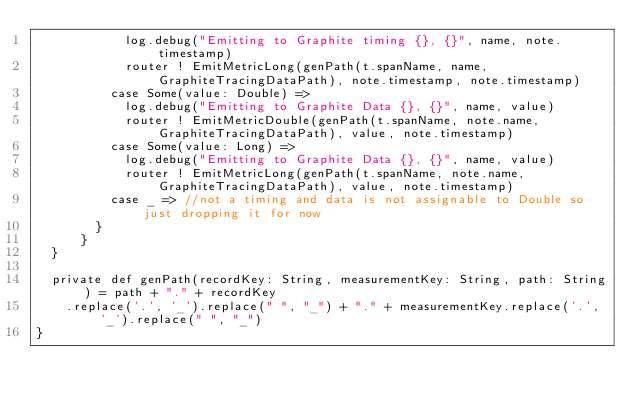Convert code to text. <code><loc_0><loc_0><loc_500><loc_500><_Scala_>            log.debug("Emitting to Graphite timing {}, {}", name, note.timestamp)
            router ! EmitMetricLong(genPath(t.spanName, name, GraphiteTracingDataPath), note.timestamp, note.timestamp)
          case Some(value: Double) =>
            log.debug("Emitting to Graphite Data {}, {}", name, value)
            router ! EmitMetricDouble(genPath(t.spanName, note.name, GraphiteTracingDataPath), value, note.timestamp)
          case Some(value: Long) =>
            log.debug("Emitting to Graphite Data {}, {}", name, value)
            router ! EmitMetricLong(genPath(t.spanName, note.name, GraphiteTracingDataPath), value, note.timestamp)
          case _ => //not a timing and data is not assignable to Double so just dropping it for now
        }
      }
  }

  private def genPath(recordKey: String, measurementKey: String, path: String) = path + "." + recordKey
    .replace('.', '_').replace(" ", "_") + "." + measurementKey.replace('.', '_').replace(" ", "_")
}
</code> 